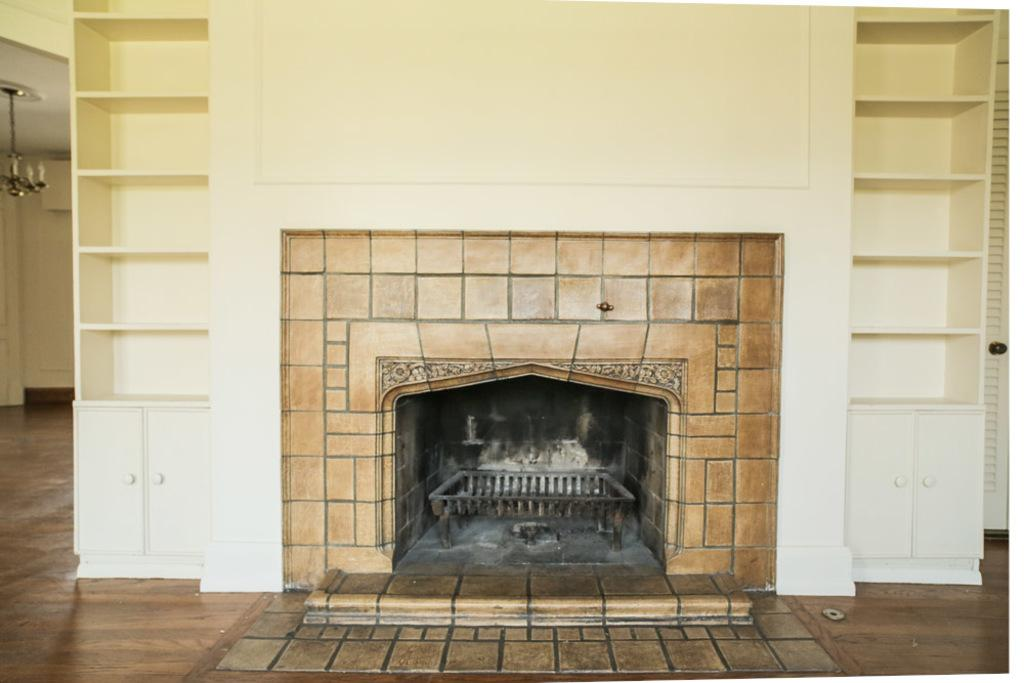What type of oven is visible in the image? There is a wooden oven in the image. What other furniture or fixtures can be seen in the image? There are cupboards in the image. What is the background of the image made of? There is a wall in the image. What type of lighting is present in the image? There is a ceiling light in the image. What surface is the oven and cupboards placed on? There is a floor in the image. How does the person in the image interact with the jam? There is no person present in the image, and therefore no interaction with jam can be observed. 